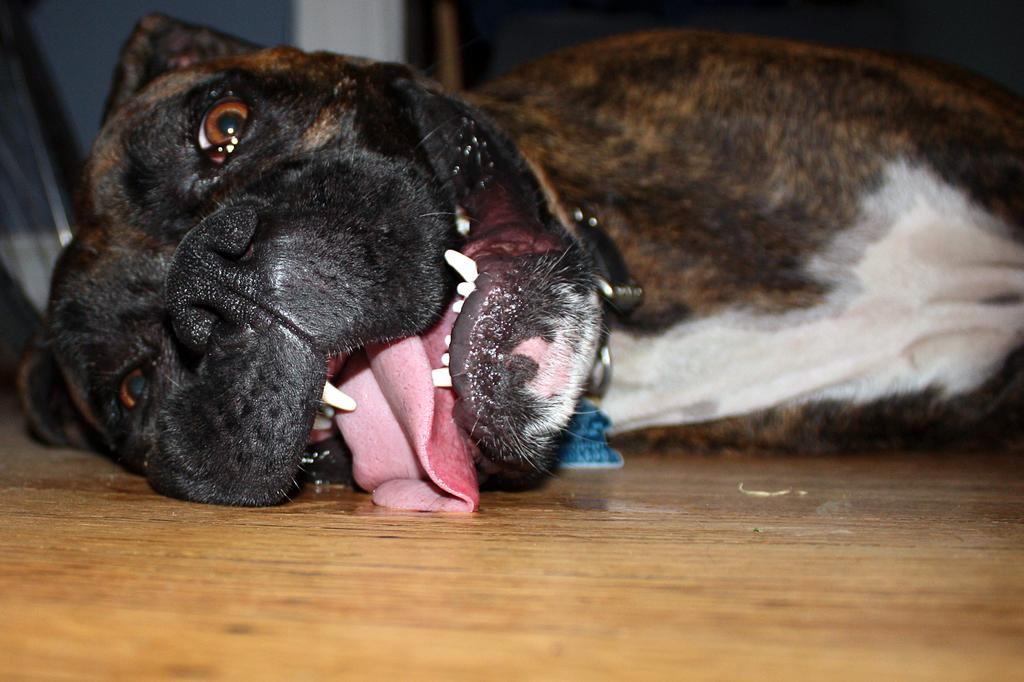What animal is present in the image? There is a dog in the image. What is the dog doing in the image? The dog is sleeping. Where is the dog located in the image? The dog is on the floor. How many sheep are present in the image? There are no sheep present in the image; it features a dog. What type of bed is the dog lying on in the image? The dog is not lying on a bed in the image; it is on the floor. 